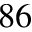Convert formula to latex. <formula><loc_0><loc_0><loc_500><loc_500>^ { 8 6 }</formula> 